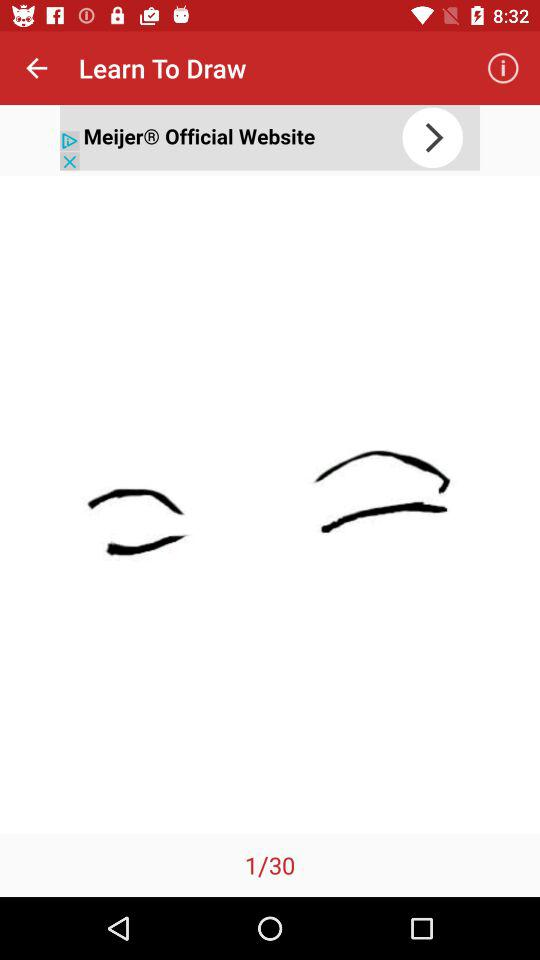How many total images are there? There are a total of 30 images. 